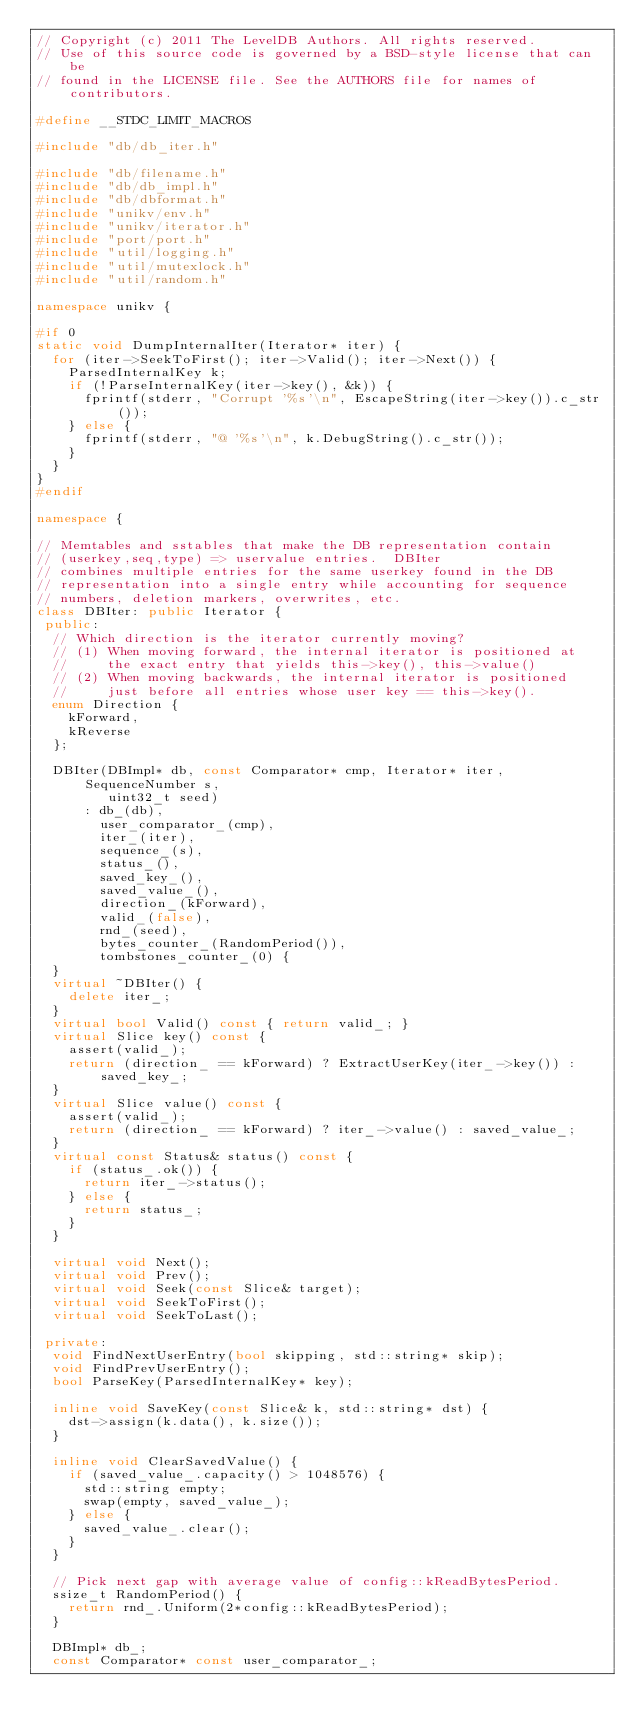Convert code to text. <code><loc_0><loc_0><loc_500><loc_500><_C++_>// Copyright (c) 2011 The LevelDB Authors. All rights reserved.
// Use of this source code is governed by a BSD-style license that can be
// found in the LICENSE file. See the AUTHORS file for names of contributors.

#define __STDC_LIMIT_MACROS

#include "db/db_iter.h"

#include "db/filename.h"
#include "db/db_impl.h"
#include "db/dbformat.h"
#include "unikv/env.h"
#include "unikv/iterator.h"
#include "port/port.h"
#include "util/logging.h"
#include "util/mutexlock.h"
#include "util/random.h"

namespace unikv {

#if 0
static void DumpInternalIter(Iterator* iter) {
  for (iter->SeekToFirst(); iter->Valid(); iter->Next()) {
    ParsedInternalKey k;
    if (!ParseInternalKey(iter->key(), &k)) {
      fprintf(stderr, "Corrupt '%s'\n", EscapeString(iter->key()).c_str());
    } else {
      fprintf(stderr, "@ '%s'\n", k.DebugString().c_str());
    }
  }
}
#endif

namespace {

// Memtables and sstables that make the DB representation contain
// (userkey,seq,type) => uservalue entries.  DBIter
// combines multiple entries for the same userkey found in the DB
// representation into a single entry while accounting for sequence
// numbers, deletion markers, overwrites, etc.
class DBIter: public Iterator {
 public:
  // Which direction is the iterator currently moving?
  // (1) When moving forward, the internal iterator is positioned at
  //     the exact entry that yields this->key(), this->value()
  // (2) When moving backwards, the internal iterator is positioned
  //     just before all entries whose user key == this->key().
  enum Direction {
    kForward,
    kReverse
  };

  DBIter(DBImpl* db, const Comparator* cmp, Iterator* iter, SequenceNumber s,
         uint32_t seed)
      : db_(db),
        user_comparator_(cmp),
        iter_(iter),
        sequence_(s),
        status_(),
        saved_key_(),
        saved_value_(),
        direction_(kForward),
        valid_(false),
        rnd_(seed),
        bytes_counter_(RandomPeriod()),
        tombstones_counter_(0) {
  }
  virtual ~DBIter() {
    delete iter_;
  }
  virtual bool Valid() const { return valid_; }
  virtual Slice key() const {
    assert(valid_);
    return (direction_ == kForward) ? ExtractUserKey(iter_->key()) : saved_key_;
  }
  virtual Slice value() const {
    assert(valid_);
    return (direction_ == kForward) ? iter_->value() : saved_value_;
  }
  virtual const Status& status() const {
    if (status_.ok()) {
      return iter_->status();
    } else {
      return status_;
    }
  }

  virtual void Next();
  virtual void Prev();
  virtual void Seek(const Slice& target);
  virtual void SeekToFirst();
  virtual void SeekToLast();

 private:
  void FindNextUserEntry(bool skipping, std::string* skip);
  void FindPrevUserEntry();
  bool ParseKey(ParsedInternalKey* key);

  inline void SaveKey(const Slice& k, std::string* dst) {
    dst->assign(k.data(), k.size());
  }

  inline void ClearSavedValue() {
    if (saved_value_.capacity() > 1048576) {
      std::string empty;
      swap(empty, saved_value_);
    } else {
      saved_value_.clear();
    }
  }

  // Pick next gap with average value of config::kReadBytesPeriod.
  ssize_t RandomPeriod() {
    return rnd_.Uniform(2*config::kReadBytesPeriod);
  }

  DBImpl* db_;
  const Comparator* const user_comparator_;</code> 